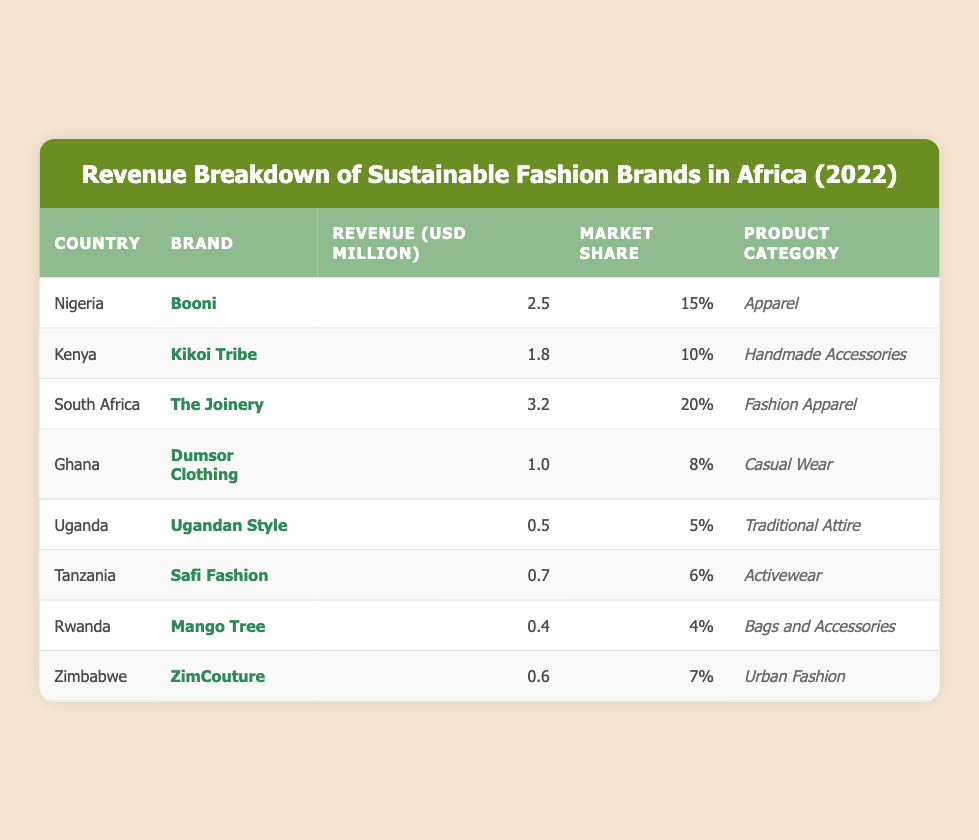What is the total revenue generated by the sustainable fashion brands listed in the table? To find the total revenue, I will sum the revenue figures for all brands listed: 2.5 + 1.8 + 3.2 + 1.0 + 0.5 + 0.7 + 0.4 + 0.6 = 10.7
Answer: 10.7 million USD Which country has the highest market share among the brands listed? I will compare the market share percentages of each brand. South Africa's The Joinery has the highest market share at 20%.
Answer: South Africa Is the revenue of Ugandan Style greater than that of Dumsor Clothing? I will compare the revenues: Ugandan Style has 0.5 million USD, and Dumsor Clothing has 1.0 million USD. Since 0.5 is less than 1.0, the statement is false.
Answer: No What is the average revenue of the brands across the different countries? To find the average, I first calculated the total revenue (10.7 million USD) and then divided it by the number of brands (8). Therefore, the average revenue is 10.7 / 8 = 1.3375.
Answer: 1.34 million USD Which brand has a revenue of 0.4 million USD? I will look through the table to identify which brand matches that revenue. The brand Mango Tree from Rwanda has a revenue of 0.4 million USD.
Answer: Mango Tree How much greater is the revenue of The Joinery compared to Kikoi Tribe? I will subtract the revenue of Kikoi Tribe (1.8 million USD) from The Joinery (3.2 million USD): 3.2 - 1.8 = 1.4 million USD.
Answer: 1.4 million USD Is Dumsor Clothing the only brand from Ghana listed in this table? I will check the table to see if there are any other brands from Ghana listed. Dumsor Clothing is the only brand mentioned, confirming this statement as true.
Answer: Yes What percentage of the total revenue does Safi Fashion represent? First, I need to find Safi Fashion's revenue (0.7 million USD) and the total revenue (10.7 million USD). I calculate (0.7 / 10.7) * 100 = 6.54%.
Answer: Approximately 6.54% Which product category generates the least revenue based on the data? I will assess the revenues per product category. Ugandan Style (0.5 million), Safi Fashion (0.7 million), Mango Tree (0.4 million), and ZimCouture (0.6 million). The lowest revenue is from Mango Tree at 0.4 million.
Answer: Bags and Accessories Which two brands together account for at least 30% of the market share? I will identify pairs of brands that, when combined, yield at least 30% market share starting from the highest percentages downwards. The Joinery (20%) + Booni (15%) = 35%, which meets the criteria.
Answer: The Joinery and Booni What is the total market share percentage of all brands from the table? To find the total market share, I will sum all individual percentages: 15 + 10 + 20 + 8 + 5 + 6 + 4 + 7 = 75%.
Answer: 75% 